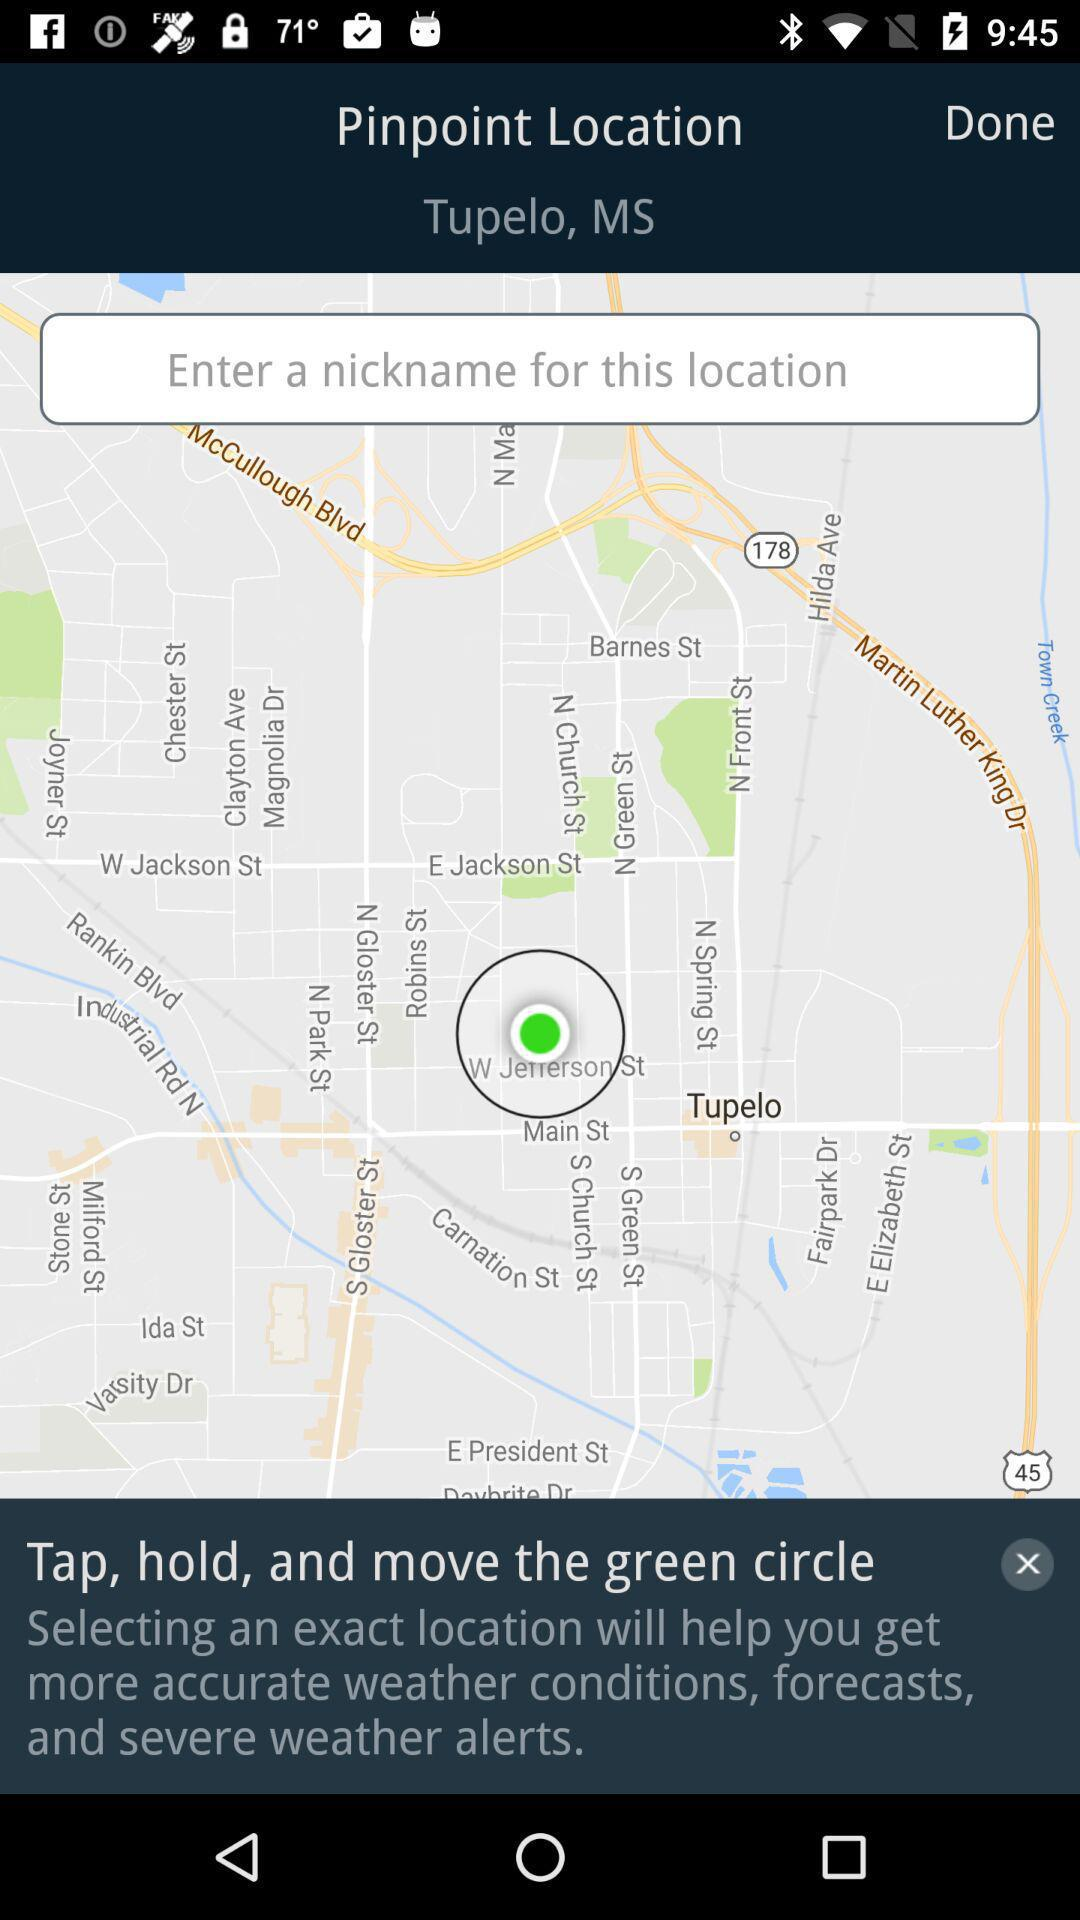How many text inputs are present on the screen?
Answer the question using a single word or phrase. 1 